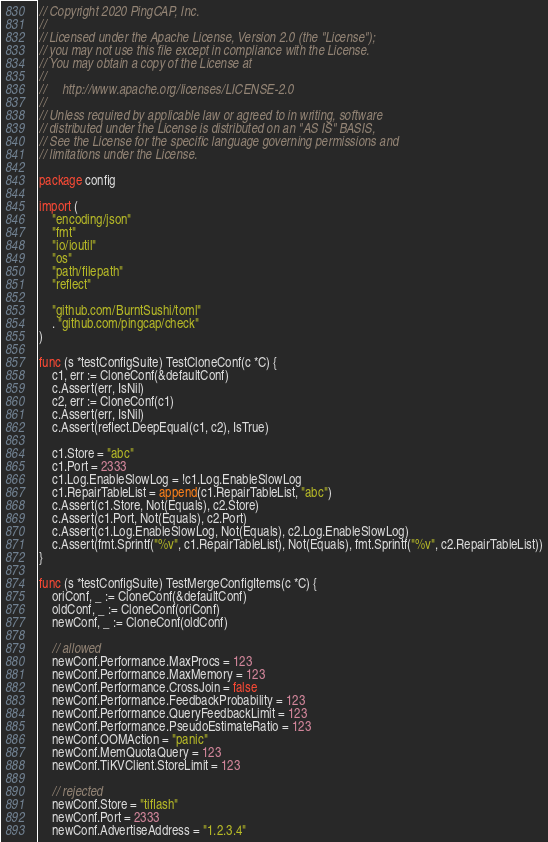<code> <loc_0><loc_0><loc_500><loc_500><_Go_>// Copyright 2020 PingCAP, Inc.
//
// Licensed under the Apache License, Version 2.0 (the "License");
// you may not use this file except in compliance with the License.
// You may obtain a copy of the License at
//
//     http://www.apache.org/licenses/LICENSE-2.0
//
// Unless required by applicable law or agreed to in writing, software
// distributed under the License is distributed on an "AS IS" BASIS,
// See the License for the specific language governing permissions and
// limitations under the License.

package config

import (
	"encoding/json"
	"fmt"
	"io/ioutil"
	"os"
	"path/filepath"
	"reflect"

	"github.com/BurntSushi/toml"
	. "github.com/pingcap/check"
)

func (s *testConfigSuite) TestCloneConf(c *C) {
	c1, err := CloneConf(&defaultConf)
	c.Assert(err, IsNil)
	c2, err := CloneConf(c1)
	c.Assert(err, IsNil)
	c.Assert(reflect.DeepEqual(c1, c2), IsTrue)

	c1.Store = "abc"
	c1.Port = 2333
	c1.Log.EnableSlowLog = !c1.Log.EnableSlowLog
	c1.RepairTableList = append(c1.RepairTableList, "abc")
	c.Assert(c1.Store, Not(Equals), c2.Store)
	c.Assert(c1.Port, Not(Equals), c2.Port)
	c.Assert(c1.Log.EnableSlowLog, Not(Equals), c2.Log.EnableSlowLog)
	c.Assert(fmt.Sprintf("%v", c1.RepairTableList), Not(Equals), fmt.Sprintf("%v", c2.RepairTableList))
}

func (s *testConfigSuite) TestMergeConfigItems(c *C) {
	oriConf, _ := CloneConf(&defaultConf)
	oldConf, _ := CloneConf(oriConf)
	newConf, _ := CloneConf(oldConf)

	// allowed
	newConf.Performance.MaxProcs = 123
	newConf.Performance.MaxMemory = 123
	newConf.Performance.CrossJoin = false
	newConf.Performance.FeedbackProbability = 123
	newConf.Performance.QueryFeedbackLimit = 123
	newConf.Performance.PseudoEstimateRatio = 123
	newConf.OOMAction = "panic"
	newConf.MemQuotaQuery = 123
	newConf.TiKVClient.StoreLimit = 123

	// rejected
	newConf.Store = "tiflash"
	newConf.Port = 2333
	newConf.AdvertiseAddress = "1.2.3.4"</code> 